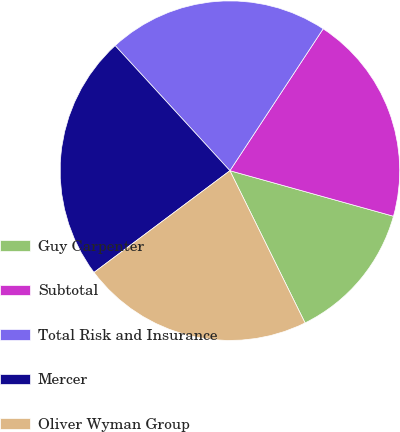<chart> <loc_0><loc_0><loc_500><loc_500><pie_chart><fcel>Guy Carpenter<fcel>Subtotal<fcel>Total Risk and Insurance<fcel>Mercer<fcel>Oliver Wyman Group<nl><fcel>13.38%<fcel>20.07%<fcel>21.07%<fcel>23.41%<fcel>22.07%<nl></chart> 